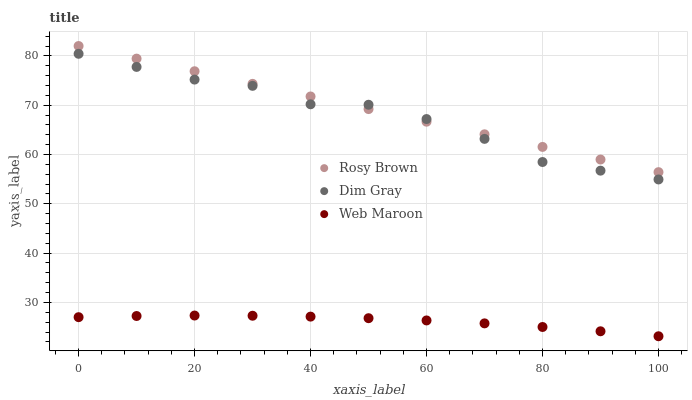Does Web Maroon have the minimum area under the curve?
Answer yes or no. Yes. Does Rosy Brown have the maximum area under the curve?
Answer yes or no. Yes. Does Rosy Brown have the minimum area under the curve?
Answer yes or no. No. Does Web Maroon have the maximum area under the curve?
Answer yes or no. No. Is Rosy Brown the smoothest?
Answer yes or no. Yes. Is Dim Gray the roughest?
Answer yes or no. Yes. Is Web Maroon the smoothest?
Answer yes or no. No. Is Web Maroon the roughest?
Answer yes or no. No. Does Web Maroon have the lowest value?
Answer yes or no. Yes. Does Rosy Brown have the lowest value?
Answer yes or no. No. Does Rosy Brown have the highest value?
Answer yes or no. Yes. Does Web Maroon have the highest value?
Answer yes or no. No. Is Web Maroon less than Dim Gray?
Answer yes or no. Yes. Is Dim Gray greater than Web Maroon?
Answer yes or no. Yes. Does Dim Gray intersect Rosy Brown?
Answer yes or no. Yes. Is Dim Gray less than Rosy Brown?
Answer yes or no. No. Is Dim Gray greater than Rosy Brown?
Answer yes or no. No. Does Web Maroon intersect Dim Gray?
Answer yes or no. No. 